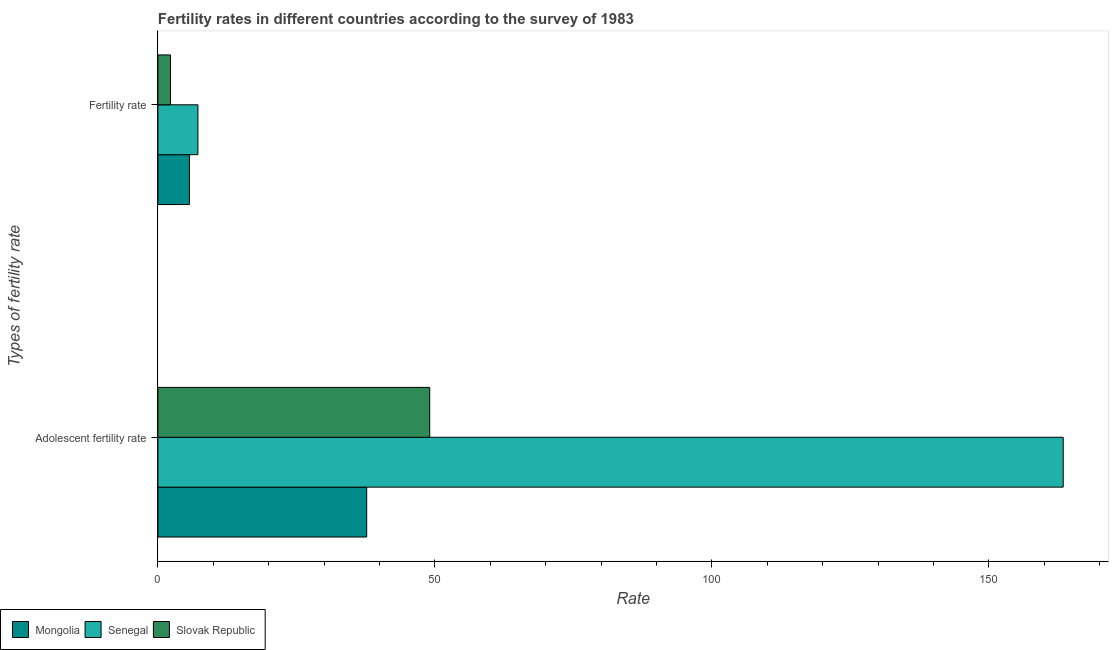How many different coloured bars are there?
Your answer should be compact. 3. Are the number of bars per tick equal to the number of legend labels?
Provide a short and direct response. Yes. How many bars are there on the 1st tick from the top?
Your response must be concise. 3. What is the label of the 2nd group of bars from the top?
Give a very brief answer. Adolescent fertility rate. What is the adolescent fertility rate in Mongolia?
Offer a terse response. 37.69. Across all countries, what is the maximum adolescent fertility rate?
Keep it short and to the point. 163.41. Across all countries, what is the minimum adolescent fertility rate?
Make the answer very short. 37.69. In which country was the fertility rate maximum?
Your answer should be compact. Senegal. In which country was the fertility rate minimum?
Offer a very short reply. Slovak Republic. What is the total fertility rate in the graph?
Your answer should be very brief. 15.2. What is the difference between the adolescent fertility rate in Mongolia and that in Slovak Republic?
Make the answer very short. -11.38. What is the difference between the fertility rate in Senegal and the adolescent fertility rate in Slovak Republic?
Keep it short and to the point. -41.84. What is the average adolescent fertility rate per country?
Provide a succinct answer. 83.39. What is the difference between the adolescent fertility rate and fertility rate in Slovak Republic?
Ensure brevity in your answer.  46.78. In how many countries, is the fertility rate greater than 20 ?
Your answer should be very brief. 0. What is the ratio of the adolescent fertility rate in Mongolia to that in Slovak Republic?
Your response must be concise. 0.77. Is the fertility rate in Senegal less than that in Slovak Republic?
Make the answer very short. No. In how many countries, is the adolescent fertility rate greater than the average adolescent fertility rate taken over all countries?
Provide a short and direct response. 1. What does the 3rd bar from the top in Adolescent fertility rate represents?
Offer a terse response. Mongolia. What does the 3rd bar from the bottom in Adolescent fertility rate represents?
Offer a very short reply. Slovak Republic. Are all the bars in the graph horizontal?
Provide a short and direct response. Yes. How many countries are there in the graph?
Provide a succinct answer. 3. Are the values on the major ticks of X-axis written in scientific E-notation?
Your response must be concise. No. Does the graph contain grids?
Keep it short and to the point. No. How are the legend labels stacked?
Keep it short and to the point. Horizontal. What is the title of the graph?
Your answer should be compact. Fertility rates in different countries according to the survey of 1983. What is the label or title of the X-axis?
Offer a very short reply. Rate. What is the label or title of the Y-axis?
Provide a short and direct response. Types of fertility rate. What is the Rate of Mongolia in Adolescent fertility rate?
Your response must be concise. 37.69. What is the Rate of Senegal in Adolescent fertility rate?
Ensure brevity in your answer.  163.41. What is the Rate in Slovak Republic in Adolescent fertility rate?
Provide a succinct answer. 49.06. What is the Rate of Mongolia in Fertility rate?
Your answer should be very brief. 5.7. What is the Rate of Senegal in Fertility rate?
Your answer should be compact. 7.22. What is the Rate in Slovak Republic in Fertility rate?
Your response must be concise. 2.28. Across all Types of fertility rate, what is the maximum Rate in Mongolia?
Offer a terse response. 37.69. Across all Types of fertility rate, what is the maximum Rate in Senegal?
Give a very brief answer. 163.41. Across all Types of fertility rate, what is the maximum Rate in Slovak Republic?
Keep it short and to the point. 49.06. Across all Types of fertility rate, what is the minimum Rate in Mongolia?
Ensure brevity in your answer.  5.7. Across all Types of fertility rate, what is the minimum Rate in Senegal?
Provide a succinct answer. 7.22. Across all Types of fertility rate, what is the minimum Rate in Slovak Republic?
Provide a succinct answer. 2.28. What is the total Rate in Mongolia in the graph?
Your answer should be very brief. 43.38. What is the total Rate of Senegal in the graph?
Keep it short and to the point. 170.64. What is the total Rate in Slovak Republic in the graph?
Offer a very short reply. 51.34. What is the difference between the Rate in Mongolia in Adolescent fertility rate and that in Fertility rate?
Offer a terse response. 31.99. What is the difference between the Rate in Senegal in Adolescent fertility rate and that in Fertility rate?
Your answer should be compact. 156.19. What is the difference between the Rate in Slovak Republic in Adolescent fertility rate and that in Fertility rate?
Provide a short and direct response. 46.78. What is the difference between the Rate in Mongolia in Adolescent fertility rate and the Rate in Senegal in Fertility rate?
Your response must be concise. 30.46. What is the difference between the Rate of Mongolia in Adolescent fertility rate and the Rate of Slovak Republic in Fertility rate?
Your answer should be very brief. 35.41. What is the difference between the Rate of Senegal in Adolescent fertility rate and the Rate of Slovak Republic in Fertility rate?
Your response must be concise. 161.13. What is the average Rate of Mongolia per Types of fertility rate?
Give a very brief answer. 21.69. What is the average Rate of Senegal per Types of fertility rate?
Keep it short and to the point. 85.32. What is the average Rate in Slovak Republic per Types of fertility rate?
Make the answer very short. 25.67. What is the difference between the Rate in Mongolia and Rate in Senegal in Adolescent fertility rate?
Your answer should be very brief. -125.73. What is the difference between the Rate of Mongolia and Rate of Slovak Republic in Adolescent fertility rate?
Keep it short and to the point. -11.38. What is the difference between the Rate of Senegal and Rate of Slovak Republic in Adolescent fertility rate?
Ensure brevity in your answer.  114.35. What is the difference between the Rate in Mongolia and Rate in Senegal in Fertility rate?
Your answer should be compact. -1.53. What is the difference between the Rate of Mongolia and Rate of Slovak Republic in Fertility rate?
Make the answer very short. 3.42. What is the difference between the Rate of Senegal and Rate of Slovak Republic in Fertility rate?
Make the answer very short. 4.95. What is the ratio of the Rate of Mongolia in Adolescent fertility rate to that in Fertility rate?
Your answer should be compact. 6.62. What is the ratio of the Rate of Senegal in Adolescent fertility rate to that in Fertility rate?
Your response must be concise. 22.62. What is the ratio of the Rate of Slovak Republic in Adolescent fertility rate to that in Fertility rate?
Provide a succinct answer. 21.52. What is the difference between the highest and the second highest Rate of Mongolia?
Ensure brevity in your answer.  31.99. What is the difference between the highest and the second highest Rate of Senegal?
Keep it short and to the point. 156.19. What is the difference between the highest and the second highest Rate of Slovak Republic?
Your answer should be very brief. 46.78. What is the difference between the highest and the lowest Rate of Mongolia?
Make the answer very short. 31.99. What is the difference between the highest and the lowest Rate of Senegal?
Offer a terse response. 156.19. What is the difference between the highest and the lowest Rate in Slovak Republic?
Provide a succinct answer. 46.78. 